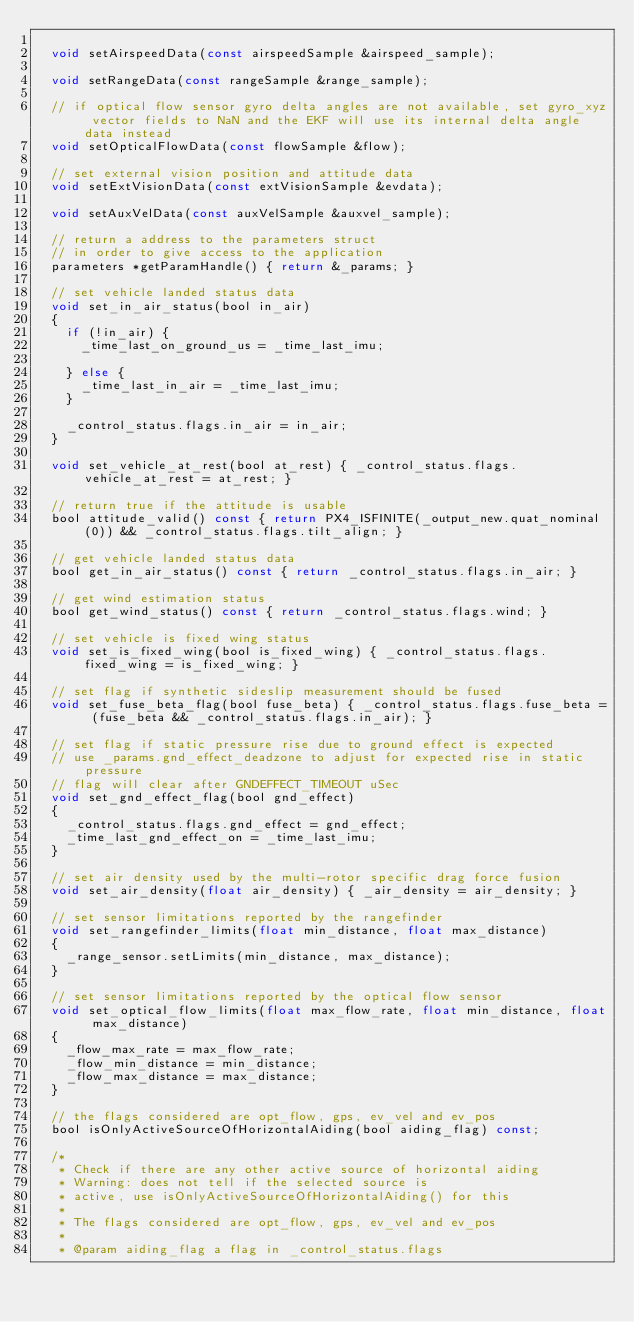<code> <loc_0><loc_0><loc_500><loc_500><_C_>
	void setAirspeedData(const airspeedSample &airspeed_sample);

	void setRangeData(const rangeSample &range_sample);

	// if optical flow sensor gyro delta angles are not available, set gyro_xyz vector fields to NaN and the EKF will use its internal delta angle data instead
	void setOpticalFlowData(const flowSample &flow);

	// set external vision position and attitude data
	void setExtVisionData(const extVisionSample &evdata);

	void setAuxVelData(const auxVelSample &auxvel_sample);

	// return a address to the parameters struct
	// in order to give access to the application
	parameters *getParamHandle() { return &_params; }

	// set vehicle landed status data
	void set_in_air_status(bool in_air)
	{
		if (!in_air) {
			_time_last_on_ground_us = _time_last_imu;

		} else {
			_time_last_in_air = _time_last_imu;
		}

		_control_status.flags.in_air = in_air;
	}

	void set_vehicle_at_rest(bool at_rest) { _control_status.flags.vehicle_at_rest = at_rest; }

	// return true if the attitude is usable
	bool attitude_valid() const { return PX4_ISFINITE(_output_new.quat_nominal(0)) && _control_status.flags.tilt_align; }

	// get vehicle landed status data
	bool get_in_air_status() const { return _control_status.flags.in_air; }

	// get wind estimation status
	bool get_wind_status() const { return _control_status.flags.wind; }

	// set vehicle is fixed wing status
	void set_is_fixed_wing(bool is_fixed_wing) { _control_status.flags.fixed_wing = is_fixed_wing; }

	// set flag if synthetic sideslip measurement should be fused
	void set_fuse_beta_flag(bool fuse_beta) { _control_status.flags.fuse_beta = (fuse_beta && _control_status.flags.in_air); }

	// set flag if static pressure rise due to ground effect is expected
	// use _params.gnd_effect_deadzone to adjust for expected rise in static pressure
	// flag will clear after GNDEFFECT_TIMEOUT uSec
	void set_gnd_effect_flag(bool gnd_effect)
	{
		_control_status.flags.gnd_effect = gnd_effect;
		_time_last_gnd_effect_on = _time_last_imu;
	}

	// set air density used by the multi-rotor specific drag force fusion
	void set_air_density(float air_density) { _air_density = air_density; }

	// set sensor limitations reported by the rangefinder
	void set_rangefinder_limits(float min_distance, float max_distance)
	{
		_range_sensor.setLimits(min_distance, max_distance);
	}

	// set sensor limitations reported by the optical flow sensor
	void set_optical_flow_limits(float max_flow_rate, float min_distance, float max_distance)
	{
		_flow_max_rate = max_flow_rate;
		_flow_min_distance = min_distance;
		_flow_max_distance = max_distance;
	}

	// the flags considered are opt_flow, gps, ev_vel and ev_pos
	bool isOnlyActiveSourceOfHorizontalAiding(bool aiding_flag) const;

	/*
	 * Check if there are any other active source of horizontal aiding
	 * Warning: does not tell if the selected source is
	 * active, use isOnlyActiveSourceOfHorizontalAiding() for this
	 *
	 * The flags considered are opt_flow, gps, ev_vel and ev_pos
	 *
	 * @param aiding_flag a flag in _control_status.flags</code> 